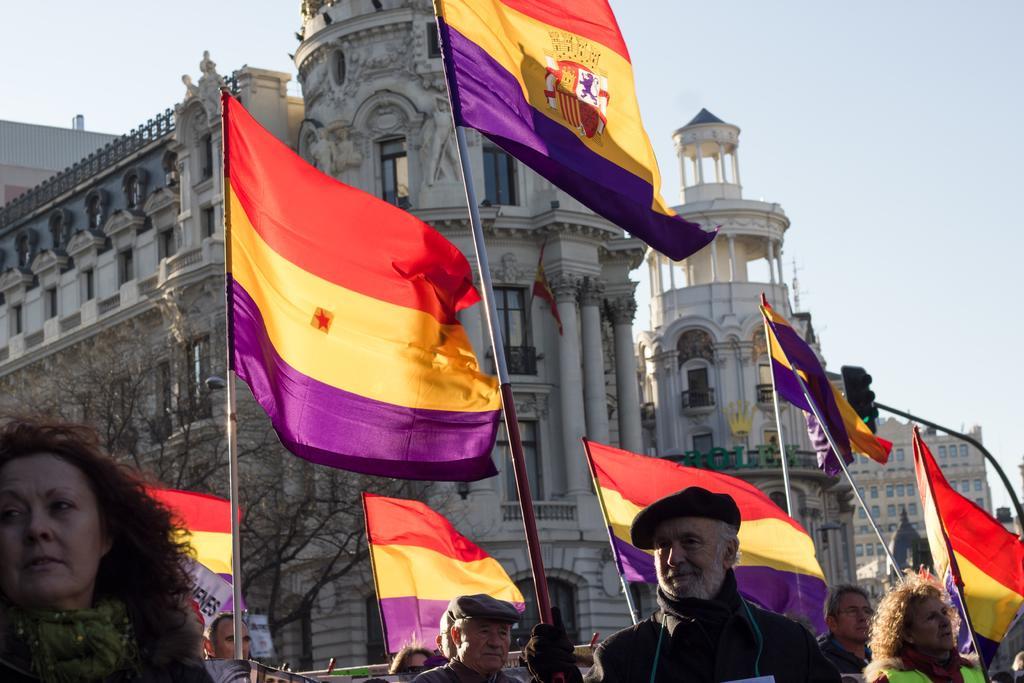Could you give a brief overview of what you see in this image? In the picture there are people standing, they are catching poles with the flags, behind them there are buildings present, there is a clear sky. 